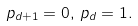<formula> <loc_0><loc_0><loc_500><loc_500>p _ { d + 1 } = 0 , \, p _ { d } = 1 .</formula> 